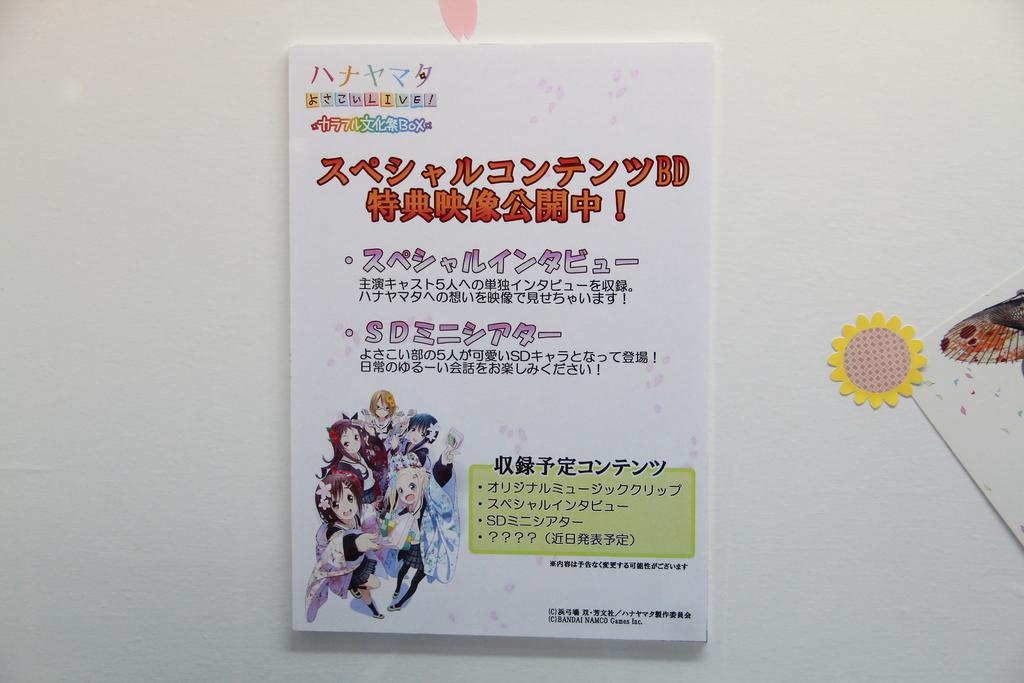What is the main subject in the middle of the image? There is a poster in the middle of the image. Where is the poster located? The poster is on a wall. What type of content is on the poster? The poster contains text and cartoon images. How many ants can be seen crawling on the poster in the image? There are no ants present on the poster in the image. What type of laborer is depicted in the cartoon images on the poster? There is no laborer depicted in the cartoon images on the poster. 